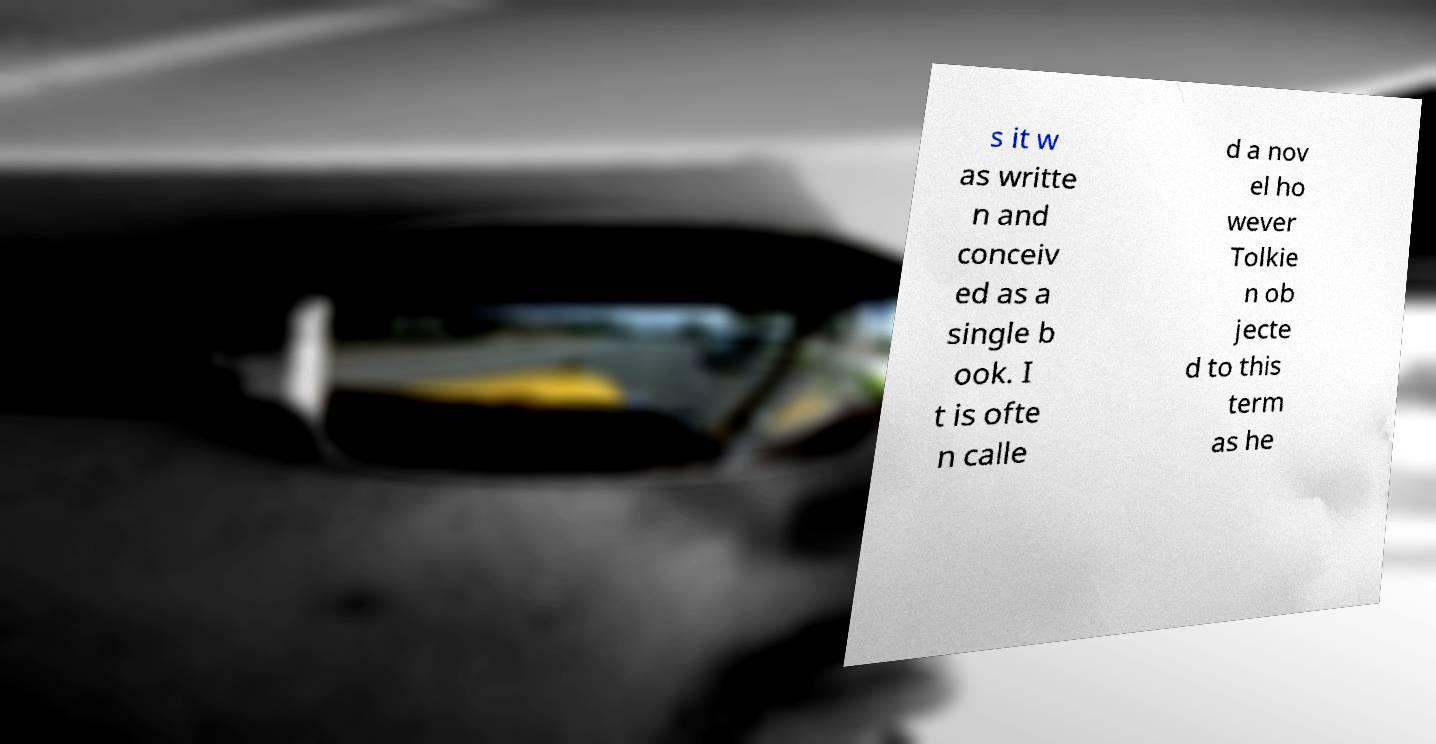Could you extract and type out the text from this image? s it w as writte n and conceiv ed as a single b ook. I t is ofte n calle d a nov el ho wever Tolkie n ob jecte d to this term as he 